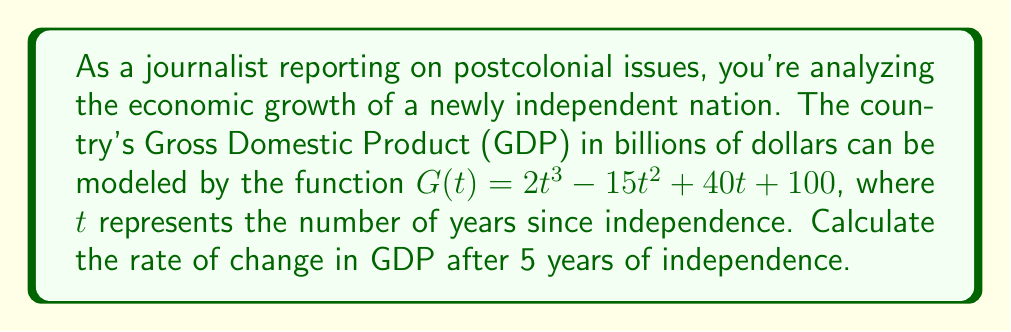Teach me how to tackle this problem. To find the rate of change in GDP after 5 years, we need to calculate the derivative of the given function $G(t)$ and evaluate it at $t=5$.

1. First, let's find the derivative of $G(t)$:
   $$G(t) = 2t^3 - 15t^2 + 40t + 100$$
   $$G'(t) = 6t^2 - 30t + 40$$

   This derivative represents the instantaneous rate of change of GDP with respect to time.

2. Now, we evaluate $G'(t)$ at $t=5$:
   $$G'(5) = 6(5^2) - 30(5) + 40$$
   $$= 6(25) - 150 + 40$$
   $$= 150 - 150 + 40$$
   $$= 40$$

3. Interpret the result:
   The rate of change in GDP after 5 years of independence is 40 billion dollars per year.

This positive value indicates that the country's economy is growing 5 years after independence, with the GDP increasing at a rate of 40 billion dollars annually at that point in time.
Answer: The rate of change in GDP after 5 years of independence is $40$ billion dollars per year. 